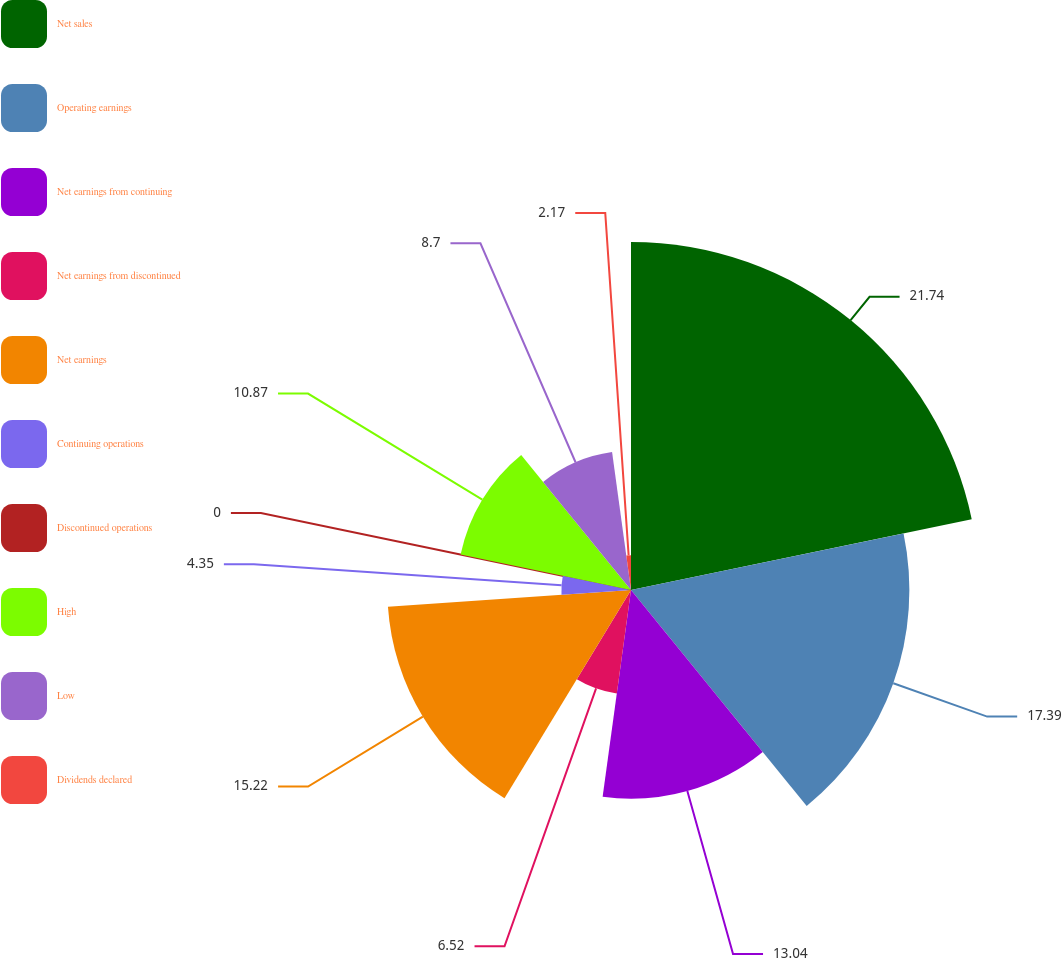<chart> <loc_0><loc_0><loc_500><loc_500><pie_chart><fcel>Net sales<fcel>Operating earnings<fcel>Net earnings from continuing<fcel>Net earnings from discontinued<fcel>Net earnings<fcel>Continuing operations<fcel>Discontinued operations<fcel>High<fcel>Low<fcel>Dividends declared<nl><fcel>21.74%<fcel>17.39%<fcel>13.04%<fcel>6.52%<fcel>15.22%<fcel>4.35%<fcel>0.0%<fcel>10.87%<fcel>8.7%<fcel>2.17%<nl></chart> 